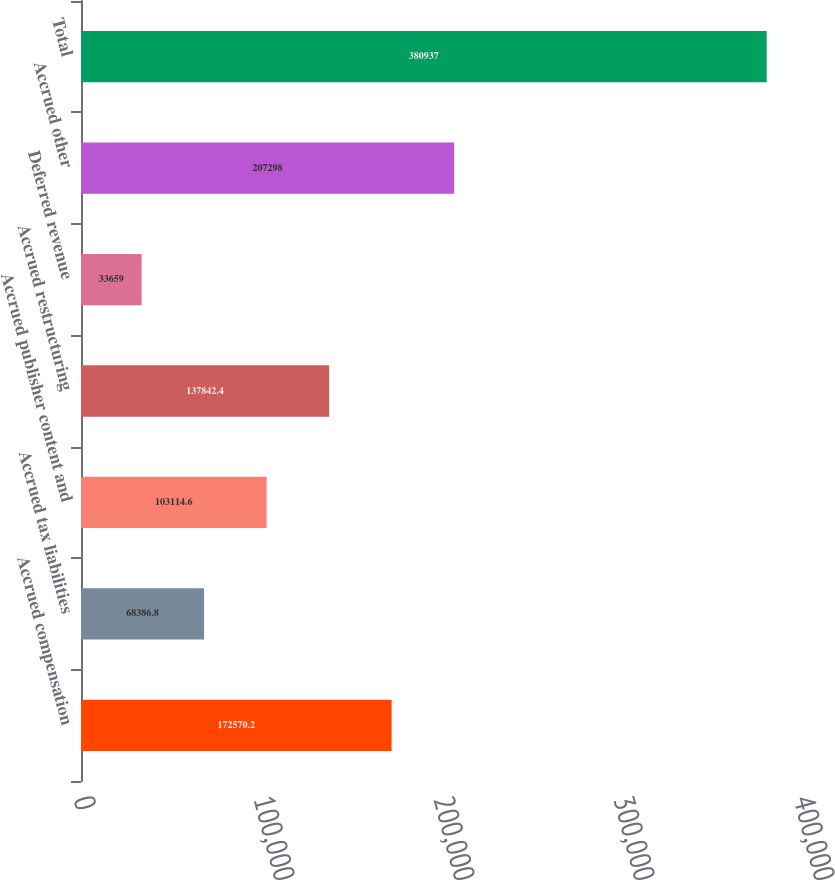<chart> <loc_0><loc_0><loc_500><loc_500><bar_chart><fcel>Accrued compensation<fcel>Accrued tax liabilities<fcel>Accrued publisher content and<fcel>Accrued restructuring<fcel>Deferred revenue<fcel>Accrued other<fcel>Total<nl><fcel>172570<fcel>68386.8<fcel>103115<fcel>137842<fcel>33659<fcel>207298<fcel>380937<nl></chart> 